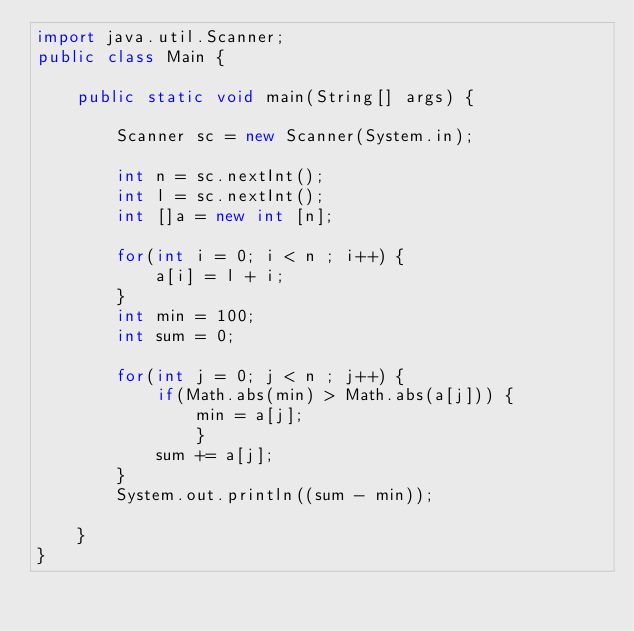Convert code to text. <code><loc_0><loc_0><loc_500><loc_500><_Java_>import java.util.Scanner;
public class Main {

	public static void main(String[] args) {
		
		Scanner sc = new Scanner(System.in);
		
		int n = sc.nextInt();
		int l = sc.nextInt();
		int []a = new int [n];
		
		for(int i = 0; i < n ; i++) {
			a[i] = l + i;
		}
		int min = 100;
		int sum = 0;
		
		for(int j = 0; j < n ; j++) {
			if(Math.abs(min) > Math.abs(a[j])) {
				min = a[j];
			    }
			sum += a[j];	
		}
		System.out.println((sum - min));
		
	}
}
</code> 